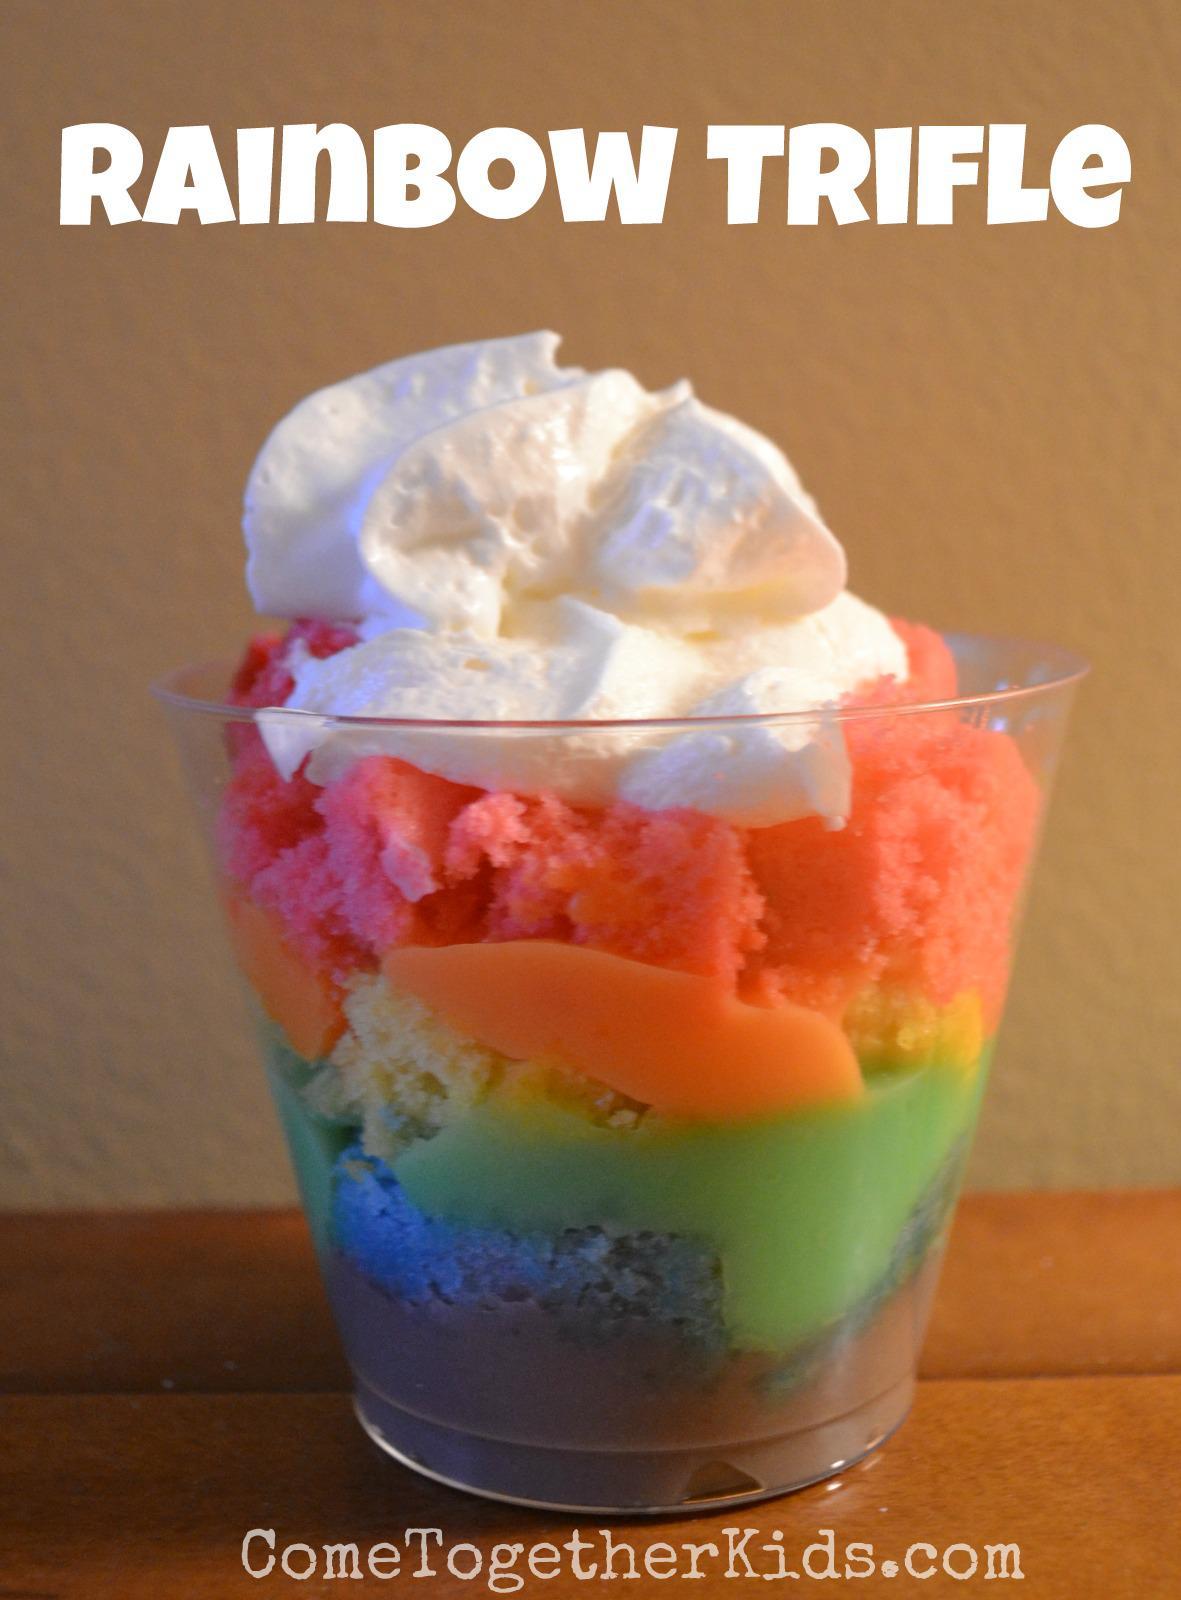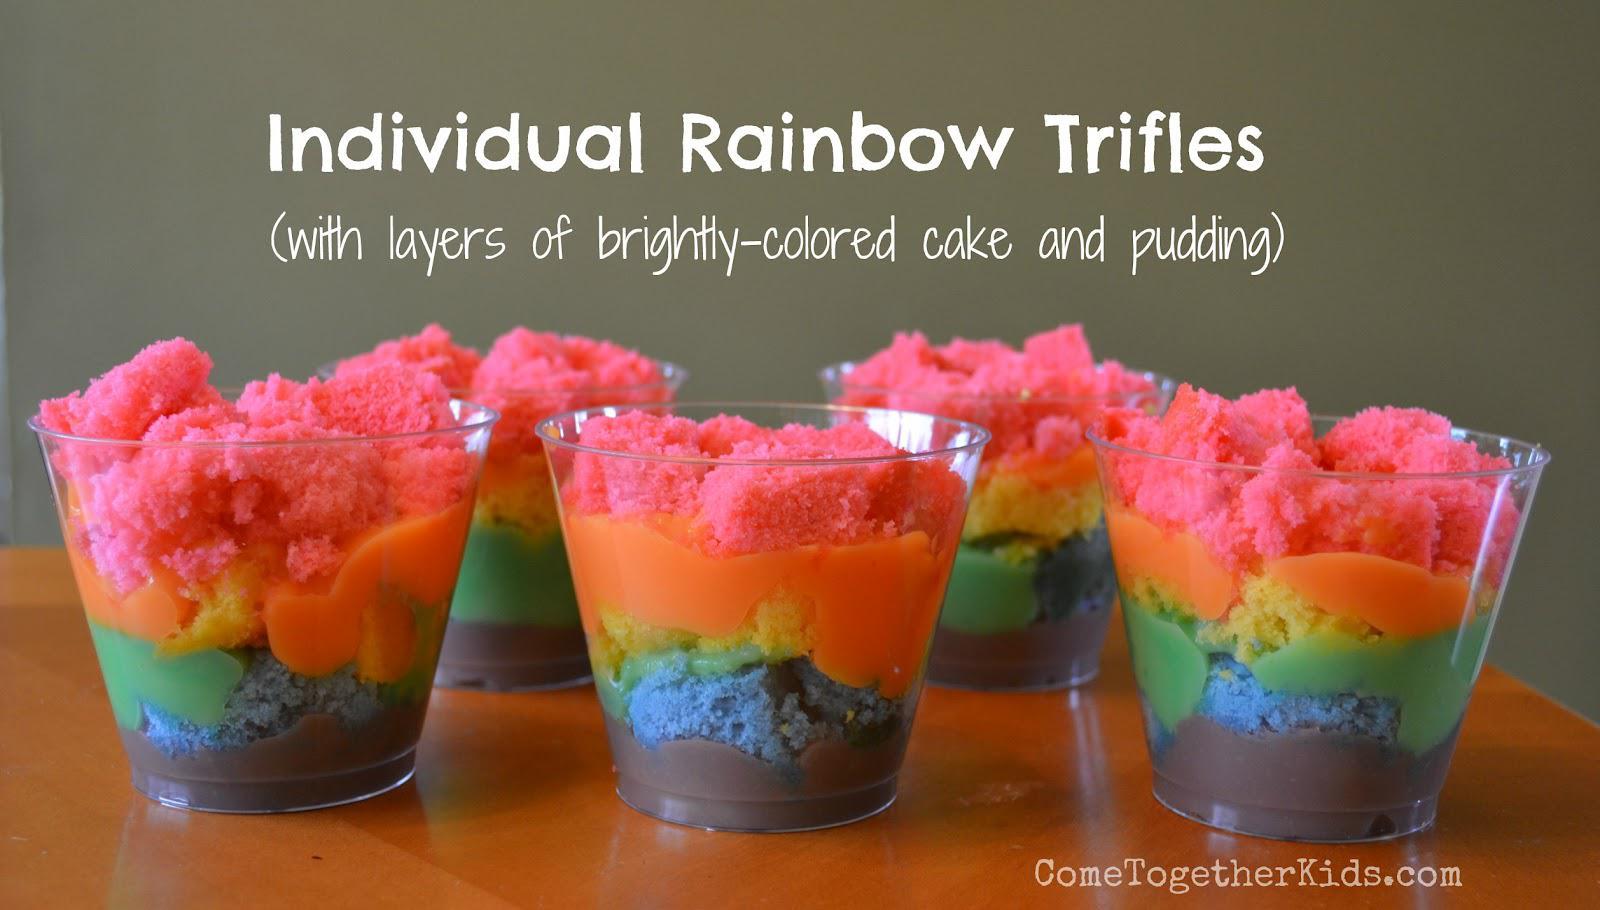The first image is the image on the left, the second image is the image on the right. Assess this claim about the two images: "An image shows at least two layered desserts served in clear non-footed glasses and each garnished with a single red berry.". Correct or not? Answer yes or no. No. The first image is the image on the left, the second image is the image on the right. Given the left and right images, does the statement "The dessert in the image on the left is served in a single sized serving." hold true? Answer yes or no. Yes. 